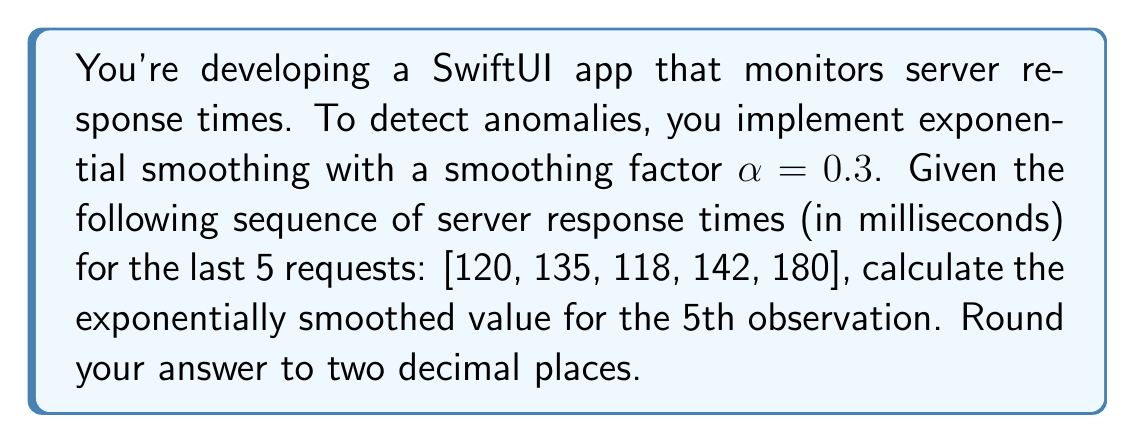Help me with this question. To solve this problem, we'll use the exponential smoothing formula:

$$S_t = \alpha Y_t + (1-\alpha)S_{t-1}$$

Where:
$S_t$ is the smoothed value at time t
$\alpha$ is the smoothing factor (0.3 in this case)
$Y_t$ is the observed value at time t

Let's calculate the smoothed values step by step:

1. Initial smoothed value ($S_0$): We'll use the first observation as our initial smoothed value.
   $S_0 = 120$

2. For t = 1:
   $S_1 = 0.3 * 135 + 0.7 * 120 = 124.5$

3. For t = 2:
   $S_2 = 0.3 * 118 + 0.7 * 124.5 = 122.55$

4. For t = 3:
   $S_3 = 0.3 * 142 + 0.7 * 122.55 = 128.385$

5. For t = 4 (the 5th observation):
   $S_4 = 0.3 * 180 + 0.7 * 128.385 = 143.8695$

Rounding to two decimal places, we get 143.87.

This approach allows for anomaly detection by comparing the actual value (180) with the smoothed value (143.87). A significant difference between these values could indicate an anomaly in server response times.
Answer: 143.87 